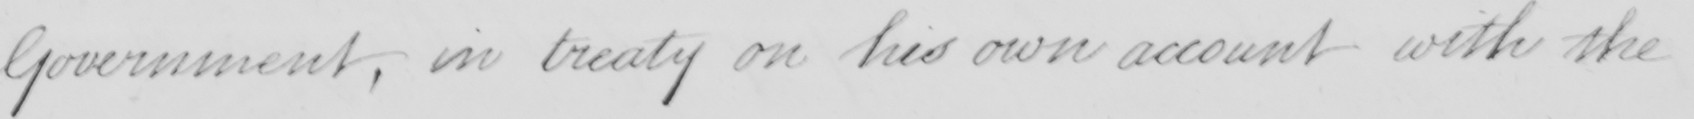What text is written in this handwritten line? Government, in treaty on his own account with the 